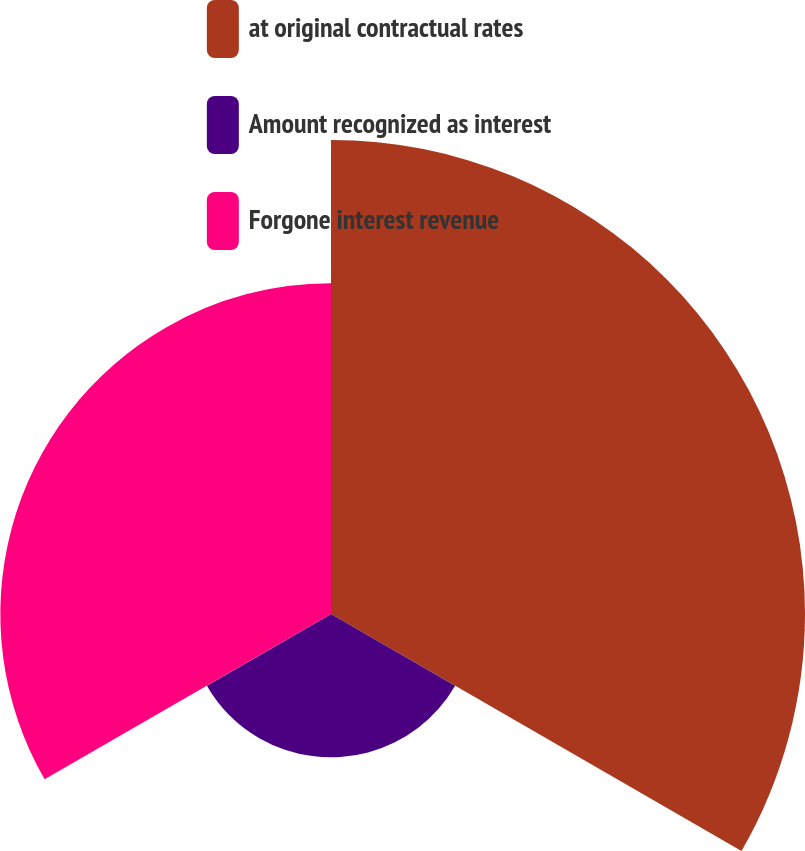Convert chart to OTSL. <chart><loc_0><loc_0><loc_500><loc_500><pie_chart><fcel>at original contractual rates<fcel>Amount recognized as interest<fcel>Forgone interest revenue<nl><fcel>50.0%<fcel>15.12%<fcel>34.88%<nl></chart> 